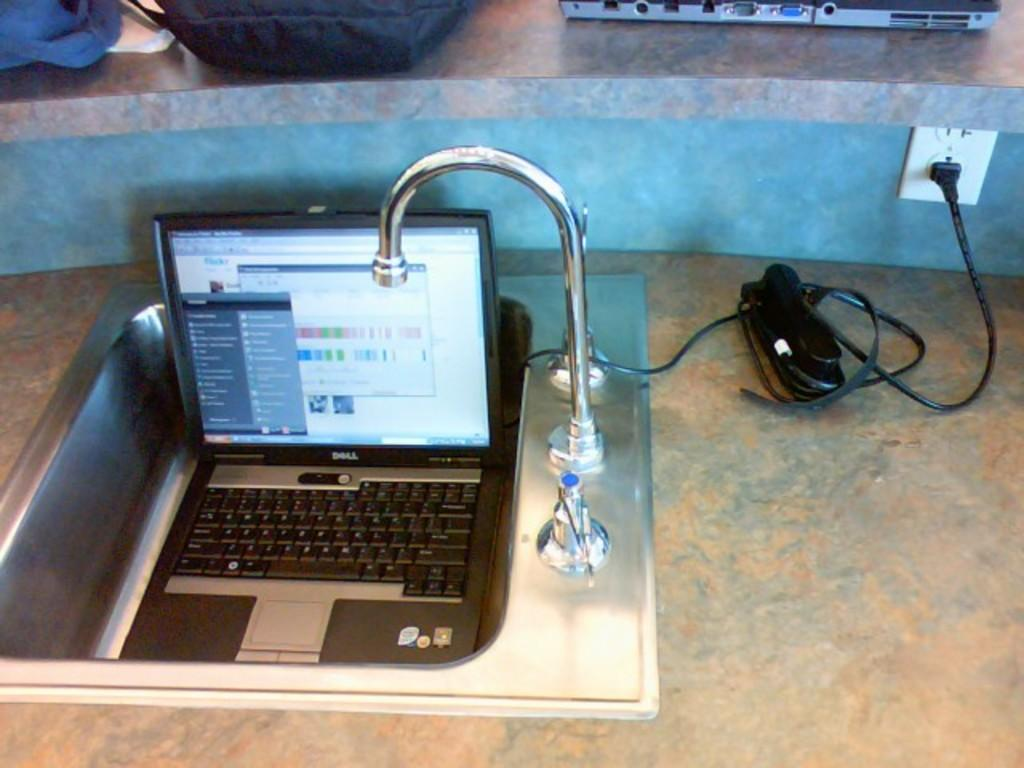What can be found in the image that is typically used for washing? There is a sink in the image. What unusual object is placed inside the sink? A laptop is present in the sink. Can you see any device that might be used to charge electronic devices in the image? Yes, there is a charger connected to a plug in the image. What type of beetle can be seen crawling on the laptop in the image? There is no beetle present in the image; the laptop is the only object inside the sink. 